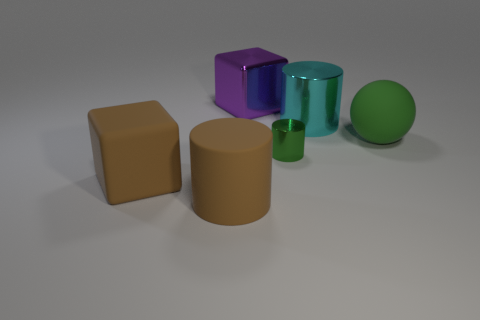Subtract all big cylinders. How many cylinders are left? 1 Add 1 tiny things. How many objects exist? 7 Subtract all spheres. How many objects are left? 5 Subtract 1 green cylinders. How many objects are left? 5 Subtract all big brown metal cylinders. Subtract all tiny metal things. How many objects are left? 5 Add 1 cyan shiny things. How many cyan shiny things are left? 2 Add 5 large metal cylinders. How many large metal cylinders exist? 6 